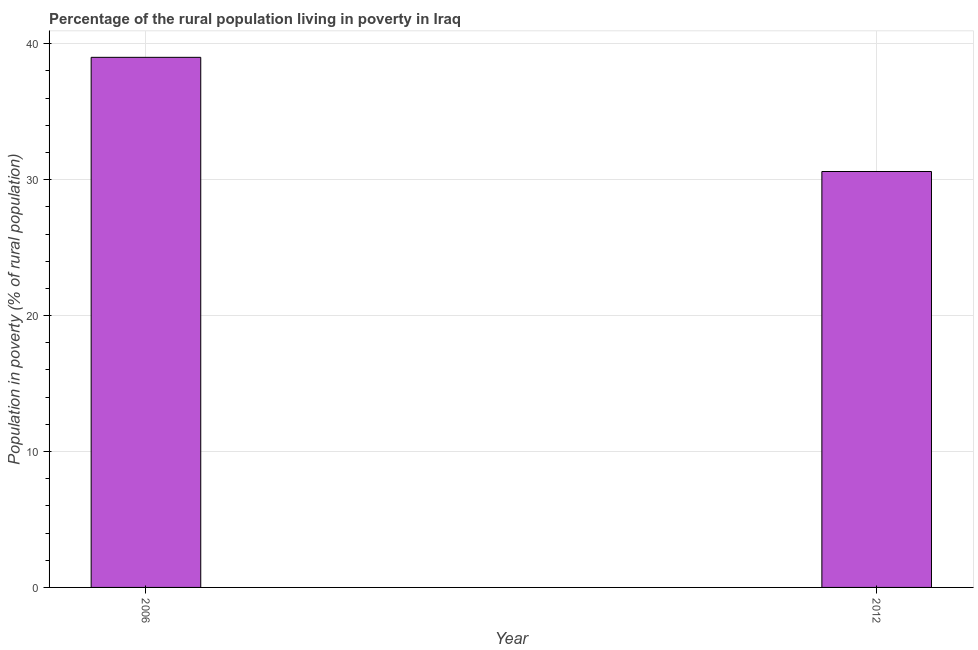Does the graph contain any zero values?
Provide a succinct answer. No. What is the title of the graph?
Your answer should be compact. Percentage of the rural population living in poverty in Iraq. What is the label or title of the X-axis?
Make the answer very short. Year. What is the label or title of the Y-axis?
Provide a succinct answer. Population in poverty (% of rural population). Across all years, what is the maximum percentage of rural population living below poverty line?
Keep it short and to the point. 39. Across all years, what is the minimum percentage of rural population living below poverty line?
Provide a short and direct response. 30.6. In which year was the percentage of rural population living below poverty line minimum?
Provide a short and direct response. 2012. What is the sum of the percentage of rural population living below poverty line?
Keep it short and to the point. 69.6. What is the difference between the percentage of rural population living below poverty line in 2006 and 2012?
Your answer should be compact. 8.4. What is the average percentage of rural population living below poverty line per year?
Your answer should be compact. 34.8. What is the median percentage of rural population living below poverty line?
Your answer should be very brief. 34.8. Do a majority of the years between 2006 and 2012 (inclusive) have percentage of rural population living below poverty line greater than 30 %?
Offer a terse response. Yes. What is the ratio of the percentage of rural population living below poverty line in 2006 to that in 2012?
Provide a short and direct response. 1.27. How many bars are there?
Your answer should be compact. 2. Are all the bars in the graph horizontal?
Ensure brevity in your answer.  No. How many years are there in the graph?
Give a very brief answer. 2. What is the difference between two consecutive major ticks on the Y-axis?
Give a very brief answer. 10. Are the values on the major ticks of Y-axis written in scientific E-notation?
Your response must be concise. No. What is the Population in poverty (% of rural population) in 2012?
Give a very brief answer. 30.6. What is the difference between the Population in poverty (% of rural population) in 2006 and 2012?
Make the answer very short. 8.4. What is the ratio of the Population in poverty (% of rural population) in 2006 to that in 2012?
Your response must be concise. 1.27. 